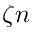<formula> <loc_0><loc_0><loc_500><loc_500>\zeta n</formula> 